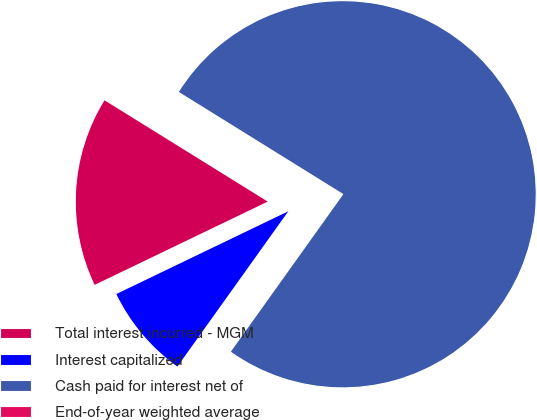<chart> <loc_0><loc_0><loc_500><loc_500><pie_chart><fcel>Total interest incurred - MGM<fcel>Interest capitalized<fcel>Cash paid for interest net of<fcel>End-of-year weighted average<nl><fcel>15.98%<fcel>7.99%<fcel>76.03%<fcel>0.0%<nl></chart> 